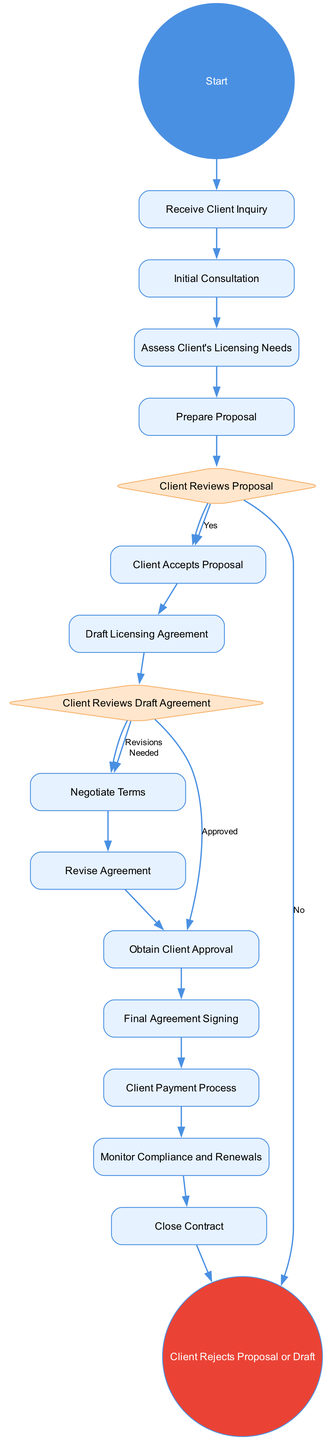What is the first activity in the diagram? The diagram begins with the "Receive Client Inquiry" node, which is the first activity outlined in the flow.
Answer: Receive Client Inquiry How many decision nodes are present in the diagram? There are two decision nodes: "Client Reviews Proposal" and "Client Reviews Draft Agreement". Thus, the total number of decision nodes is two.
Answer: 2 What happens after the "Client Reviews Proposal"? Following the "Client Reviews Proposal", the flow branches into two possibilities: if the client accepts the proposal, it leads to "Client Accepts Proposal"; if not, it leads to "Client Rejects Proposal or Draft".
Answer: Client Accepts Proposal or Client Rejects Proposal or Draft What is the last activity before closing the contract? The final activity before "Close Contract" is "Monitor Compliance and Renewals", indicating compliance monitoring is crucial before concluding the agreement.
Answer: Monitor Compliance and Renewals What indicates the client's approval in the agreement drafting process? The node "Obtain Client Approval" indicates that the client has approved the drafted licensing agreement, acting as a confirmation step.
Answer: Obtain Client Approval What are the two possible outcomes after the client reviews the draft agreement? The outcomes are "Negotiate Terms" if revisions are needed or "Obtain Client Approval" if approved, showcasing the options available based on the client’s feedback.
Answer: Negotiate Terms or Obtain Client Approval How many total activities are there in the diagram? The diagram lists 13 activities, which includes all nodes that represent processes within the licensing agreement management.
Answer: 13 What is the outcome if the proposal or draft is rejected by the client? If the client rejects the proposal or draft, the process flows to the end node labeled "Client Rejects Proposal or Draft", indicating termination of that particular path.
Answer: Client Rejects Proposal or Draft 